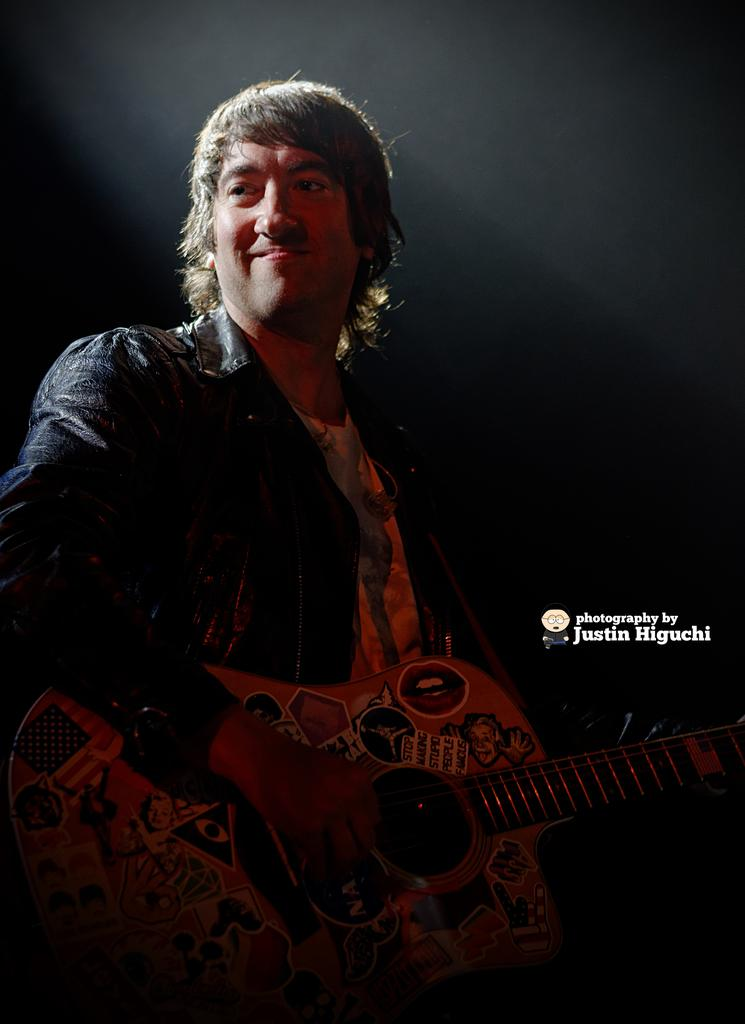Who is the main subject in the image? There is a man in the image. What is the man doing in the image? The man is standing and playing a guitar. How does the man appear to feel in the image? The man has a smile on his face, suggesting he is happy or enjoying himself. How many children are playing with the bulb in the image? There are no children or bulbs present in the image; it features a man playing a guitar. What type of cracker is the man holding in the image? There is no cracker present in the image; the man is holding a guitar. 